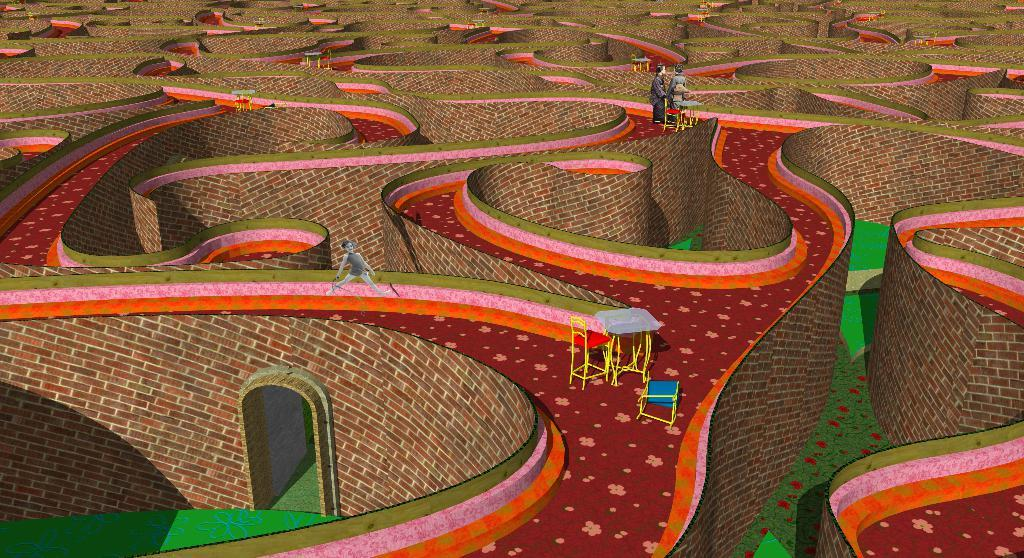What type of pictures are present in the image? There are animated pictures in the image. What type of furniture is visible in the image? There are tables and chairs in the image. What type of structure is present in the image? There are walls in the image. What type of cushion is on the ground in the image? There is no cushion or ground present in the image; it features animated pictures, tables, chairs, and walls. What type of writing instrument is being used by the characters in the image? There is no indication of any writing instruments being used in the image, as it features animated pictures, tables, chairs, and walls. 